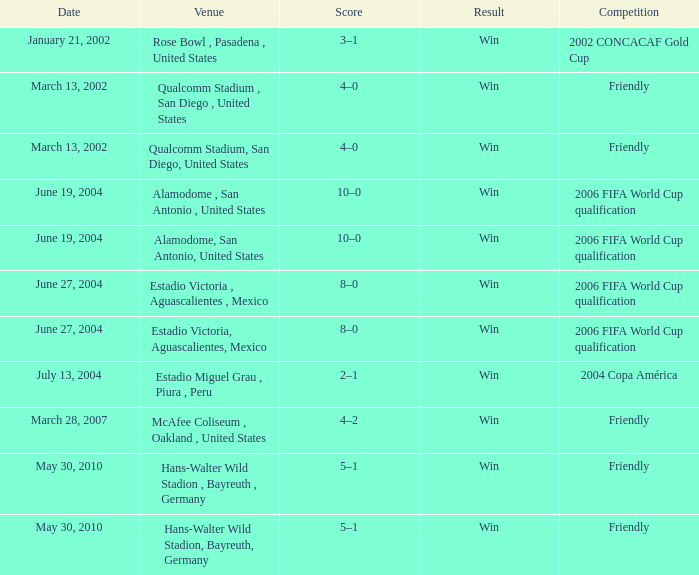When was the 2006 fifa world cup qualification match played at the alamodome in san antonio, united states? June 19, 2004, June 19, 2004. 